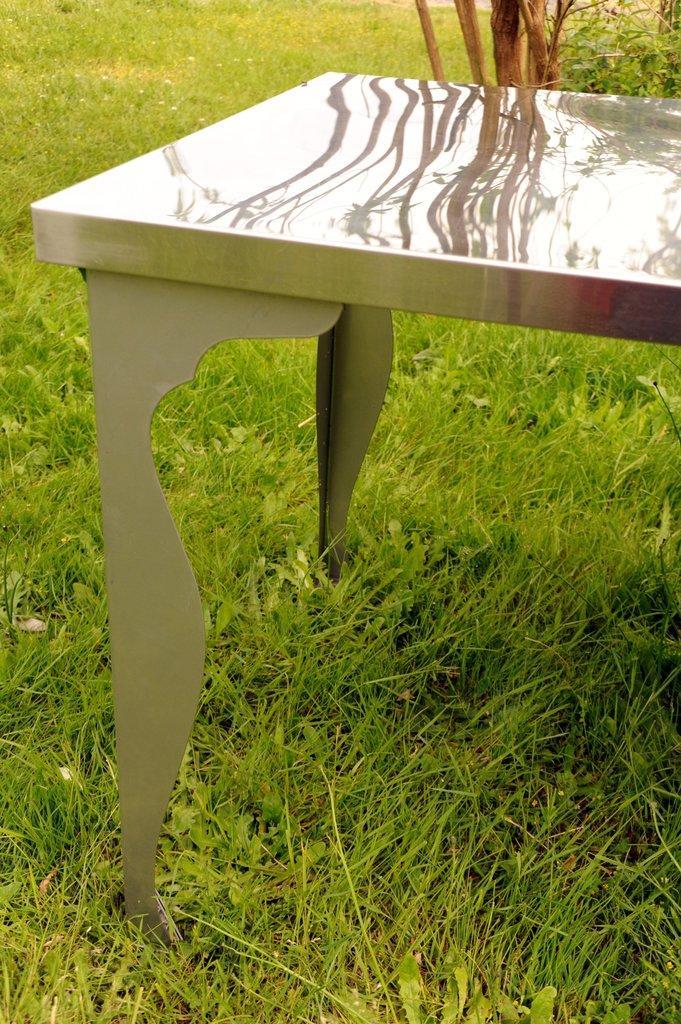Can you describe this image briefly? In the picture we can see a grass surface on it we can see a table and behind it we can see some plant. 